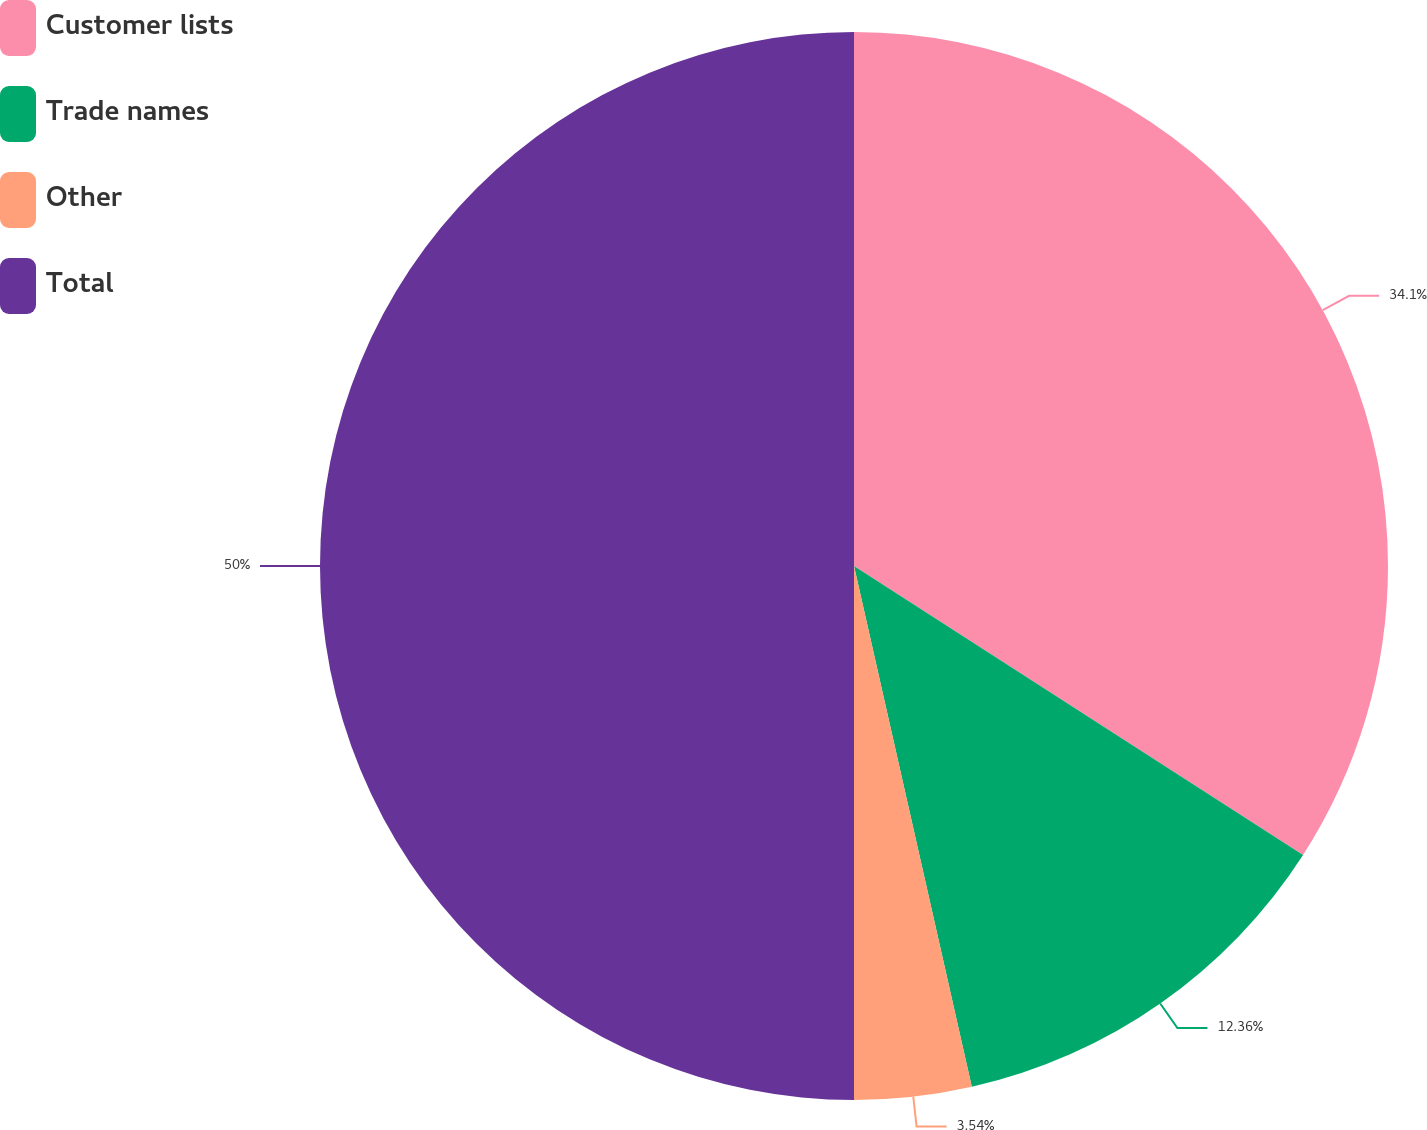Convert chart. <chart><loc_0><loc_0><loc_500><loc_500><pie_chart><fcel>Customer lists<fcel>Trade names<fcel>Other<fcel>Total<nl><fcel>34.1%<fcel>12.36%<fcel>3.54%<fcel>50.0%<nl></chart> 